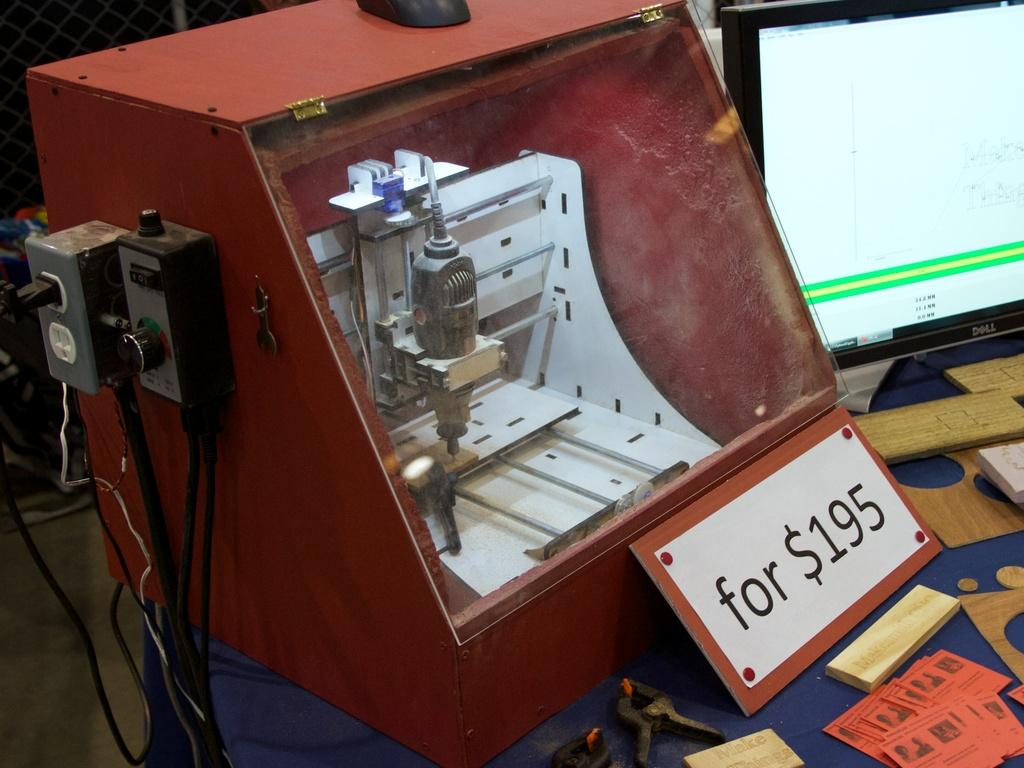Provide a one-sentence caption for the provided image. 195 dollars is printed on the sign in front of this machine. 